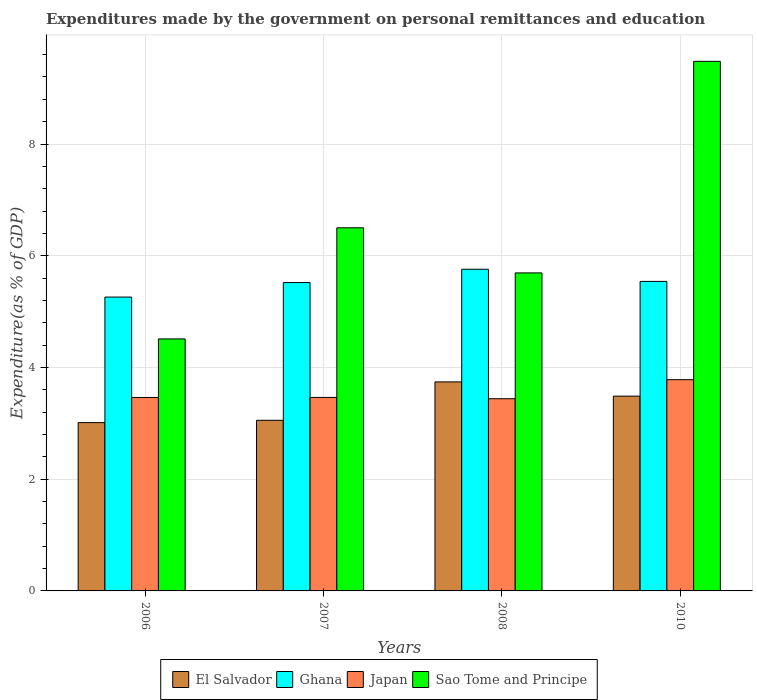How many different coloured bars are there?
Offer a terse response. 4. How many groups of bars are there?
Offer a very short reply. 4. Are the number of bars on each tick of the X-axis equal?
Your response must be concise. Yes. How many bars are there on the 1st tick from the left?
Provide a short and direct response. 4. How many bars are there on the 3rd tick from the right?
Offer a terse response. 4. In how many cases, is the number of bars for a given year not equal to the number of legend labels?
Your answer should be very brief. 0. What is the expenditures made by the government on personal remittances and education in Ghana in 2008?
Provide a short and direct response. 5.76. Across all years, what is the maximum expenditures made by the government on personal remittances and education in Ghana?
Make the answer very short. 5.76. Across all years, what is the minimum expenditures made by the government on personal remittances and education in Sao Tome and Principe?
Offer a very short reply. 4.51. What is the total expenditures made by the government on personal remittances and education in El Salvador in the graph?
Offer a very short reply. 13.3. What is the difference between the expenditures made by the government on personal remittances and education in Japan in 2006 and that in 2010?
Offer a very short reply. -0.32. What is the difference between the expenditures made by the government on personal remittances and education in Ghana in 2008 and the expenditures made by the government on personal remittances and education in Japan in 2007?
Ensure brevity in your answer.  2.29. What is the average expenditures made by the government on personal remittances and education in Sao Tome and Principe per year?
Your answer should be very brief. 6.55. In the year 2010, what is the difference between the expenditures made by the government on personal remittances and education in Sao Tome and Principe and expenditures made by the government on personal remittances and education in Ghana?
Your response must be concise. 3.94. What is the ratio of the expenditures made by the government on personal remittances and education in Ghana in 2006 to that in 2007?
Your response must be concise. 0.95. Is the expenditures made by the government on personal remittances and education in Japan in 2008 less than that in 2010?
Offer a very short reply. Yes. Is the difference between the expenditures made by the government on personal remittances and education in Sao Tome and Principe in 2007 and 2008 greater than the difference between the expenditures made by the government on personal remittances and education in Ghana in 2007 and 2008?
Give a very brief answer. Yes. What is the difference between the highest and the second highest expenditures made by the government on personal remittances and education in Sao Tome and Principe?
Ensure brevity in your answer.  2.98. What is the difference between the highest and the lowest expenditures made by the government on personal remittances and education in El Salvador?
Make the answer very short. 0.73. In how many years, is the expenditures made by the government on personal remittances and education in Ghana greater than the average expenditures made by the government on personal remittances and education in Ghana taken over all years?
Offer a terse response. 3. Is it the case that in every year, the sum of the expenditures made by the government on personal remittances and education in Ghana and expenditures made by the government on personal remittances and education in Sao Tome and Principe is greater than the sum of expenditures made by the government on personal remittances and education in El Salvador and expenditures made by the government on personal remittances and education in Japan?
Your response must be concise. No. What does the 4th bar from the left in 2008 represents?
Ensure brevity in your answer.  Sao Tome and Principe. What does the 4th bar from the right in 2008 represents?
Provide a short and direct response. El Salvador. How many bars are there?
Your answer should be compact. 16. Are all the bars in the graph horizontal?
Offer a terse response. No. How many years are there in the graph?
Keep it short and to the point. 4. How many legend labels are there?
Your response must be concise. 4. What is the title of the graph?
Give a very brief answer. Expenditures made by the government on personal remittances and education. Does "Central African Republic" appear as one of the legend labels in the graph?
Your answer should be very brief. No. What is the label or title of the X-axis?
Provide a short and direct response. Years. What is the label or title of the Y-axis?
Offer a very short reply. Expenditure(as % of GDP). What is the Expenditure(as % of GDP) in El Salvador in 2006?
Your answer should be compact. 3.01. What is the Expenditure(as % of GDP) of Ghana in 2006?
Provide a short and direct response. 5.26. What is the Expenditure(as % of GDP) of Japan in 2006?
Provide a short and direct response. 3.46. What is the Expenditure(as % of GDP) in Sao Tome and Principe in 2006?
Ensure brevity in your answer.  4.51. What is the Expenditure(as % of GDP) in El Salvador in 2007?
Offer a very short reply. 3.05. What is the Expenditure(as % of GDP) in Ghana in 2007?
Keep it short and to the point. 5.52. What is the Expenditure(as % of GDP) of Japan in 2007?
Your response must be concise. 3.46. What is the Expenditure(as % of GDP) in Sao Tome and Principe in 2007?
Ensure brevity in your answer.  6.5. What is the Expenditure(as % of GDP) in El Salvador in 2008?
Make the answer very short. 3.74. What is the Expenditure(as % of GDP) in Ghana in 2008?
Offer a very short reply. 5.76. What is the Expenditure(as % of GDP) of Japan in 2008?
Offer a very short reply. 3.44. What is the Expenditure(as % of GDP) of Sao Tome and Principe in 2008?
Provide a short and direct response. 5.69. What is the Expenditure(as % of GDP) in El Salvador in 2010?
Ensure brevity in your answer.  3.49. What is the Expenditure(as % of GDP) in Ghana in 2010?
Provide a succinct answer. 5.54. What is the Expenditure(as % of GDP) of Japan in 2010?
Your response must be concise. 3.78. What is the Expenditure(as % of GDP) of Sao Tome and Principe in 2010?
Your answer should be very brief. 9.48. Across all years, what is the maximum Expenditure(as % of GDP) of El Salvador?
Your response must be concise. 3.74. Across all years, what is the maximum Expenditure(as % of GDP) in Ghana?
Your answer should be very brief. 5.76. Across all years, what is the maximum Expenditure(as % of GDP) of Japan?
Your response must be concise. 3.78. Across all years, what is the maximum Expenditure(as % of GDP) in Sao Tome and Principe?
Your answer should be compact. 9.48. Across all years, what is the minimum Expenditure(as % of GDP) in El Salvador?
Your answer should be compact. 3.01. Across all years, what is the minimum Expenditure(as % of GDP) in Ghana?
Give a very brief answer. 5.26. Across all years, what is the minimum Expenditure(as % of GDP) of Japan?
Make the answer very short. 3.44. Across all years, what is the minimum Expenditure(as % of GDP) in Sao Tome and Principe?
Your answer should be compact. 4.51. What is the total Expenditure(as % of GDP) in El Salvador in the graph?
Offer a very short reply. 13.3. What is the total Expenditure(as % of GDP) of Ghana in the graph?
Your response must be concise. 22.08. What is the total Expenditure(as % of GDP) in Japan in the graph?
Give a very brief answer. 14.15. What is the total Expenditure(as % of GDP) of Sao Tome and Principe in the graph?
Provide a short and direct response. 26.18. What is the difference between the Expenditure(as % of GDP) of El Salvador in 2006 and that in 2007?
Give a very brief answer. -0.04. What is the difference between the Expenditure(as % of GDP) in Ghana in 2006 and that in 2007?
Your answer should be compact. -0.26. What is the difference between the Expenditure(as % of GDP) in Japan in 2006 and that in 2007?
Your answer should be compact. -0. What is the difference between the Expenditure(as % of GDP) of Sao Tome and Principe in 2006 and that in 2007?
Provide a short and direct response. -1.99. What is the difference between the Expenditure(as % of GDP) of El Salvador in 2006 and that in 2008?
Make the answer very short. -0.73. What is the difference between the Expenditure(as % of GDP) in Ghana in 2006 and that in 2008?
Give a very brief answer. -0.5. What is the difference between the Expenditure(as % of GDP) of Japan in 2006 and that in 2008?
Your response must be concise. 0.02. What is the difference between the Expenditure(as % of GDP) of Sao Tome and Principe in 2006 and that in 2008?
Ensure brevity in your answer.  -1.18. What is the difference between the Expenditure(as % of GDP) of El Salvador in 2006 and that in 2010?
Give a very brief answer. -0.47. What is the difference between the Expenditure(as % of GDP) in Ghana in 2006 and that in 2010?
Give a very brief answer. -0.28. What is the difference between the Expenditure(as % of GDP) of Japan in 2006 and that in 2010?
Keep it short and to the point. -0.32. What is the difference between the Expenditure(as % of GDP) of Sao Tome and Principe in 2006 and that in 2010?
Give a very brief answer. -4.97. What is the difference between the Expenditure(as % of GDP) in El Salvador in 2007 and that in 2008?
Your answer should be very brief. -0.69. What is the difference between the Expenditure(as % of GDP) of Ghana in 2007 and that in 2008?
Your answer should be compact. -0.24. What is the difference between the Expenditure(as % of GDP) of Japan in 2007 and that in 2008?
Your answer should be compact. 0.02. What is the difference between the Expenditure(as % of GDP) of Sao Tome and Principe in 2007 and that in 2008?
Provide a succinct answer. 0.81. What is the difference between the Expenditure(as % of GDP) of El Salvador in 2007 and that in 2010?
Offer a very short reply. -0.43. What is the difference between the Expenditure(as % of GDP) in Ghana in 2007 and that in 2010?
Make the answer very short. -0.02. What is the difference between the Expenditure(as % of GDP) in Japan in 2007 and that in 2010?
Your answer should be very brief. -0.32. What is the difference between the Expenditure(as % of GDP) in Sao Tome and Principe in 2007 and that in 2010?
Provide a short and direct response. -2.98. What is the difference between the Expenditure(as % of GDP) of El Salvador in 2008 and that in 2010?
Make the answer very short. 0.26. What is the difference between the Expenditure(as % of GDP) of Ghana in 2008 and that in 2010?
Your answer should be very brief. 0.22. What is the difference between the Expenditure(as % of GDP) in Japan in 2008 and that in 2010?
Make the answer very short. -0.34. What is the difference between the Expenditure(as % of GDP) of Sao Tome and Principe in 2008 and that in 2010?
Keep it short and to the point. -3.79. What is the difference between the Expenditure(as % of GDP) of El Salvador in 2006 and the Expenditure(as % of GDP) of Ghana in 2007?
Make the answer very short. -2.51. What is the difference between the Expenditure(as % of GDP) of El Salvador in 2006 and the Expenditure(as % of GDP) of Japan in 2007?
Make the answer very short. -0.45. What is the difference between the Expenditure(as % of GDP) in El Salvador in 2006 and the Expenditure(as % of GDP) in Sao Tome and Principe in 2007?
Ensure brevity in your answer.  -3.49. What is the difference between the Expenditure(as % of GDP) of Ghana in 2006 and the Expenditure(as % of GDP) of Japan in 2007?
Make the answer very short. 1.8. What is the difference between the Expenditure(as % of GDP) in Ghana in 2006 and the Expenditure(as % of GDP) in Sao Tome and Principe in 2007?
Offer a very short reply. -1.24. What is the difference between the Expenditure(as % of GDP) of Japan in 2006 and the Expenditure(as % of GDP) of Sao Tome and Principe in 2007?
Make the answer very short. -3.04. What is the difference between the Expenditure(as % of GDP) of El Salvador in 2006 and the Expenditure(as % of GDP) of Ghana in 2008?
Your answer should be very brief. -2.75. What is the difference between the Expenditure(as % of GDP) in El Salvador in 2006 and the Expenditure(as % of GDP) in Japan in 2008?
Your response must be concise. -0.43. What is the difference between the Expenditure(as % of GDP) of El Salvador in 2006 and the Expenditure(as % of GDP) of Sao Tome and Principe in 2008?
Offer a very short reply. -2.68. What is the difference between the Expenditure(as % of GDP) of Ghana in 2006 and the Expenditure(as % of GDP) of Japan in 2008?
Provide a short and direct response. 1.82. What is the difference between the Expenditure(as % of GDP) of Ghana in 2006 and the Expenditure(as % of GDP) of Sao Tome and Principe in 2008?
Your response must be concise. -0.43. What is the difference between the Expenditure(as % of GDP) of Japan in 2006 and the Expenditure(as % of GDP) of Sao Tome and Principe in 2008?
Your answer should be very brief. -2.23. What is the difference between the Expenditure(as % of GDP) in El Salvador in 2006 and the Expenditure(as % of GDP) in Ghana in 2010?
Your answer should be very brief. -2.53. What is the difference between the Expenditure(as % of GDP) of El Salvador in 2006 and the Expenditure(as % of GDP) of Japan in 2010?
Give a very brief answer. -0.77. What is the difference between the Expenditure(as % of GDP) in El Salvador in 2006 and the Expenditure(as % of GDP) in Sao Tome and Principe in 2010?
Offer a terse response. -6.47. What is the difference between the Expenditure(as % of GDP) of Ghana in 2006 and the Expenditure(as % of GDP) of Japan in 2010?
Ensure brevity in your answer.  1.48. What is the difference between the Expenditure(as % of GDP) of Ghana in 2006 and the Expenditure(as % of GDP) of Sao Tome and Principe in 2010?
Make the answer very short. -4.22. What is the difference between the Expenditure(as % of GDP) in Japan in 2006 and the Expenditure(as % of GDP) in Sao Tome and Principe in 2010?
Your answer should be very brief. -6.02. What is the difference between the Expenditure(as % of GDP) in El Salvador in 2007 and the Expenditure(as % of GDP) in Ghana in 2008?
Provide a succinct answer. -2.7. What is the difference between the Expenditure(as % of GDP) of El Salvador in 2007 and the Expenditure(as % of GDP) of Japan in 2008?
Provide a short and direct response. -0.39. What is the difference between the Expenditure(as % of GDP) of El Salvador in 2007 and the Expenditure(as % of GDP) of Sao Tome and Principe in 2008?
Offer a very short reply. -2.64. What is the difference between the Expenditure(as % of GDP) of Ghana in 2007 and the Expenditure(as % of GDP) of Japan in 2008?
Provide a succinct answer. 2.08. What is the difference between the Expenditure(as % of GDP) in Ghana in 2007 and the Expenditure(as % of GDP) in Sao Tome and Principe in 2008?
Offer a terse response. -0.17. What is the difference between the Expenditure(as % of GDP) in Japan in 2007 and the Expenditure(as % of GDP) in Sao Tome and Principe in 2008?
Your response must be concise. -2.23. What is the difference between the Expenditure(as % of GDP) in El Salvador in 2007 and the Expenditure(as % of GDP) in Ghana in 2010?
Provide a short and direct response. -2.49. What is the difference between the Expenditure(as % of GDP) in El Salvador in 2007 and the Expenditure(as % of GDP) in Japan in 2010?
Make the answer very short. -0.73. What is the difference between the Expenditure(as % of GDP) in El Salvador in 2007 and the Expenditure(as % of GDP) in Sao Tome and Principe in 2010?
Give a very brief answer. -6.42. What is the difference between the Expenditure(as % of GDP) in Ghana in 2007 and the Expenditure(as % of GDP) in Japan in 2010?
Ensure brevity in your answer.  1.74. What is the difference between the Expenditure(as % of GDP) of Ghana in 2007 and the Expenditure(as % of GDP) of Sao Tome and Principe in 2010?
Offer a terse response. -3.96. What is the difference between the Expenditure(as % of GDP) of Japan in 2007 and the Expenditure(as % of GDP) of Sao Tome and Principe in 2010?
Offer a terse response. -6.02. What is the difference between the Expenditure(as % of GDP) of El Salvador in 2008 and the Expenditure(as % of GDP) of Ghana in 2010?
Your answer should be very brief. -1.8. What is the difference between the Expenditure(as % of GDP) of El Salvador in 2008 and the Expenditure(as % of GDP) of Japan in 2010?
Provide a succinct answer. -0.04. What is the difference between the Expenditure(as % of GDP) in El Salvador in 2008 and the Expenditure(as % of GDP) in Sao Tome and Principe in 2010?
Keep it short and to the point. -5.74. What is the difference between the Expenditure(as % of GDP) in Ghana in 2008 and the Expenditure(as % of GDP) in Japan in 2010?
Offer a very short reply. 1.98. What is the difference between the Expenditure(as % of GDP) of Ghana in 2008 and the Expenditure(as % of GDP) of Sao Tome and Principe in 2010?
Your answer should be very brief. -3.72. What is the difference between the Expenditure(as % of GDP) in Japan in 2008 and the Expenditure(as % of GDP) in Sao Tome and Principe in 2010?
Your answer should be very brief. -6.04. What is the average Expenditure(as % of GDP) in El Salvador per year?
Offer a very short reply. 3.32. What is the average Expenditure(as % of GDP) in Ghana per year?
Make the answer very short. 5.52. What is the average Expenditure(as % of GDP) in Japan per year?
Your answer should be very brief. 3.54. What is the average Expenditure(as % of GDP) in Sao Tome and Principe per year?
Offer a very short reply. 6.55. In the year 2006, what is the difference between the Expenditure(as % of GDP) of El Salvador and Expenditure(as % of GDP) of Ghana?
Make the answer very short. -2.25. In the year 2006, what is the difference between the Expenditure(as % of GDP) in El Salvador and Expenditure(as % of GDP) in Japan?
Offer a very short reply. -0.45. In the year 2006, what is the difference between the Expenditure(as % of GDP) of El Salvador and Expenditure(as % of GDP) of Sao Tome and Principe?
Offer a terse response. -1.5. In the year 2006, what is the difference between the Expenditure(as % of GDP) in Ghana and Expenditure(as % of GDP) in Japan?
Provide a short and direct response. 1.8. In the year 2006, what is the difference between the Expenditure(as % of GDP) in Ghana and Expenditure(as % of GDP) in Sao Tome and Principe?
Your response must be concise. 0.75. In the year 2006, what is the difference between the Expenditure(as % of GDP) in Japan and Expenditure(as % of GDP) in Sao Tome and Principe?
Your answer should be compact. -1.05. In the year 2007, what is the difference between the Expenditure(as % of GDP) in El Salvador and Expenditure(as % of GDP) in Ghana?
Your answer should be compact. -2.47. In the year 2007, what is the difference between the Expenditure(as % of GDP) of El Salvador and Expenditure(as % of GDP) of Japan?
Keep it short and to the point. -0.41. In the year 2007, what is the difference between the Expenditure(as % of GDP) in El Salvador and Expenditure(as % of GDP) in Sao Tome and Principe?
Provide a short and direct response. -3.45. In the year 2007, what is the difference between the Expenditure(as % of GDP) of Ghana and Expenditure(as % of GDP) of Japan?
Your response must be concise. 2.06. In the year 2007, what is the difference between the Expenditure(as % of GDP) in Ghana and Expenditure(as % of GDP) in Sao Tome and Principe?
Give a very brief answer. -0.98. In the year 2007, what is the difference between the Expenditure(as % of GDP) in Japan and Expenditure(as % of GDP) in Sao Tome and Principe?
Your answer should be very brief. -3.04. In the year 2008, what is the difference between the Expenditure(as % of GDP) of El Salvador and Expenditure(as % of GDP) of Ghana?
Ensure brevity in your answer.  -2.02. In the year 2008, what is the difference between the Expenditure(as % of GDP) in El Salvador and Expenditure(as % of GDP) in Japan?
Give a very brief answer. 0.3. In the year 2008, what is the difference between the Expenditure(as % of GDP) in El Salvador and Expenditure(as % of GDP) in Sao Tome and Principe?
Keep it short and to the point. -1.95. In the year 2008, what is the difference between the Expenditure(as % of GDP) in Ghana and Expenditure(as % of GDP) in Japan?
Keep it short and to the point. 2.32. In the year 2008, what is the difference between the Expenditure(as % of GDP) in Ghana and Expenditure(as % of GDP) in Sao Tome and Principe?
Provide a succinct answer. 0.07. In the year 2008, what is the difference between the Expenditure(as % of GDP) in Japan and Expenditure(as % of GDP) in Sao Tome and Principe?
Your answer should be very brief. -2.25. In the year 2010, what is the difference between the Expenditure(as % of GDP) of El Salvador and Expenditure(as % of GDP) of Ghana?
Make the answer very short. -2.05. In the year 2010, what is the difference between the Expenditure(as % of GDP) in El Salvador and Expenditure(as % of GDP) in Japan?
Ensure brevity in your answer.  -0.29. In the year 2010, what is the difference between the Expenditure(as % of GDP) of El Salvador and Expenditure(as % of GDP) of Sao Tome and Principe?
Your response must be concise. -5.99. In the year 2010, what is the difference between the Expenditure(as % of GDP) in Ghana and Expenditure(as % of GDP) in Japan?
Provide a succinct answer. 1.76. In the year 2010, what is the difference between the Expenditure(as % of GDP) in Ghana and Expenditure(as % of GDP) in Sao Tome and Principe?
Keep it short and to the point. -3.94. In the year 2010, what is the difference between the Expenditure(as % of GDP) in Japan and Expenditure(as % of GDP) in Sao Tome and Principe?
Offer a terse response. -5.7. What is the ratio of the Expenditure(as % of GDP) of El Salvador in 2006 to that in 2007?
Your response must be concise. 0.99. What is the ratio of the Expenditure(as % of GDP) in Ghana in 2006 to that in 2007?
Offer a very short reply. 0.95. What is the ratio of the Expenditure(as % of GDP) in Japan in 2006 to that in 2007?
Make the answer very short. 1. What is the ratio of the Expenditure(as % of GDP) in Sao Tome and Principe in 2006 to that in 2007?
Offer a very short reply. 0.69. What is the ratio of the Expenditure(as % of GDP) in El Salvador in 2006 to that in 2008?
Your answer should be compact. 0.81. What is the ratio of the Expenditure(as % of GDP) of Ghana in 2006 to that in 2008?
Offer a terse response. 0.91. What is the ratio of the Expenditure(as % of GDP) in Sao Tome and Principe in 2006 to that in 2008?
Ensure brevity in your answer.  0.79. What is the ratio of the Expenditure(as % of GDP) of El Salvador in 2006 to that in 2010?
Make the answer very short. 0.86. What is the ratio of the Expenditure(as % of GDP) in Ghana in 2006 to that in 2010?
Your answer should be very brief. 0.95. What is the ratio of the Expenditure(as % of GDP) of Japan in 2006 to that in 2010?
Keep it short and to the point. 0.92. What is the ratio of the Expenditure(as % of GDP) of Sao Tome and Principe in 2006 to that in 2010?
Ensure brevity in your answer.  0.48. What is the ratio of the Expenditure(as % of GDP) in El Salvador in 2007 to that in 2008?
Offer a very short reply. 0.82. What is the ratio of the Expenditure(as % of GDP) of Ghana in 2007 to that in 2008?
Ensure brevity in your answer.  0.96. What is the ratio of the Expenditure(as % of GDP) of Japan in 2007 to that in 2008?
Give a very brief answer. 1.01. What is the ratio of the Expenditure(as % of GDP) in Sao Tome and Principe in 2007 to that in 2008?
Offer a very short reply. 1.14. What is the ratio of the Expenditure(as % of GDP) of El Salvador in 2007 to that in 2010?
Give a very brief answer. 0.88. What is the ratio of the Expenditure(as % of GDP) in Ghana in 2007 to that in 2010?
Your answer should be compact. 1. What is the ratio of the Expenditure(as % of GDP) in Japan in 2007 to that in 2010?
Your response must be concise. 0.92. What is the ratio of the Expenditure(as % of GDP) of Sao Tome and Principe in 2007 to that in 2010?
Give a very brief answer. 0.69. What is the ratio of the Expenditure(as % of GDP) of El Salvador in 2008 to that in 2010?
Provide a short and direct response. 1.07. What is the ratio of the Expenditure(as % of GDP) in Ghana in 2008 to that in 2010?
Provide a short and direct response. 1.04. What is the ratio of the Expenditure(as % of GDP) in Japan in 2008 to that in 2010?
Make the answer very short. 0.91. What is the ratio of the Expenditure(as % of GDP) in Sao Tome and Principe in 2008 to that in 2010?
Provide a short and direct response. 0.6. What is the difference between the highest and the second highest Expenditure(as % of GDP) in El Salvador?
Ensure brevity in your answer.  0.26. What is the difference between the highest and the second highest Expenditure(as % of GDP) of Ghana?
Ensure brevity in your answer.  0.22. What is the difference between the highest and the second highest Expenditure(as % of GDP) in Japan?
Your answer should be very brief. 0.32. What is the difference between the highest and the second highest Expenditure(as % of GDP) of Sao Tome and Principe?
Provide a succinct answer. 2.98. What is the difference between the highest and the lowest Expenditure(as % of GDP) in El Salvador?
Provide a succinct answer. 0.73. What is the difference between the highest and the lowest Expenditure(as % of GDP) in Ghana?
Provide a short and direct response. 0.5. What is the difference between the highest and the lowest Expenditure(as % of GDP) of Japan?
Make the answer very short. 0.34. What is the difference between the highest and the lowest Expenditure(as % of GDP) of Sao Tome and Principe?
Keep it short and to the point. 4.97. 